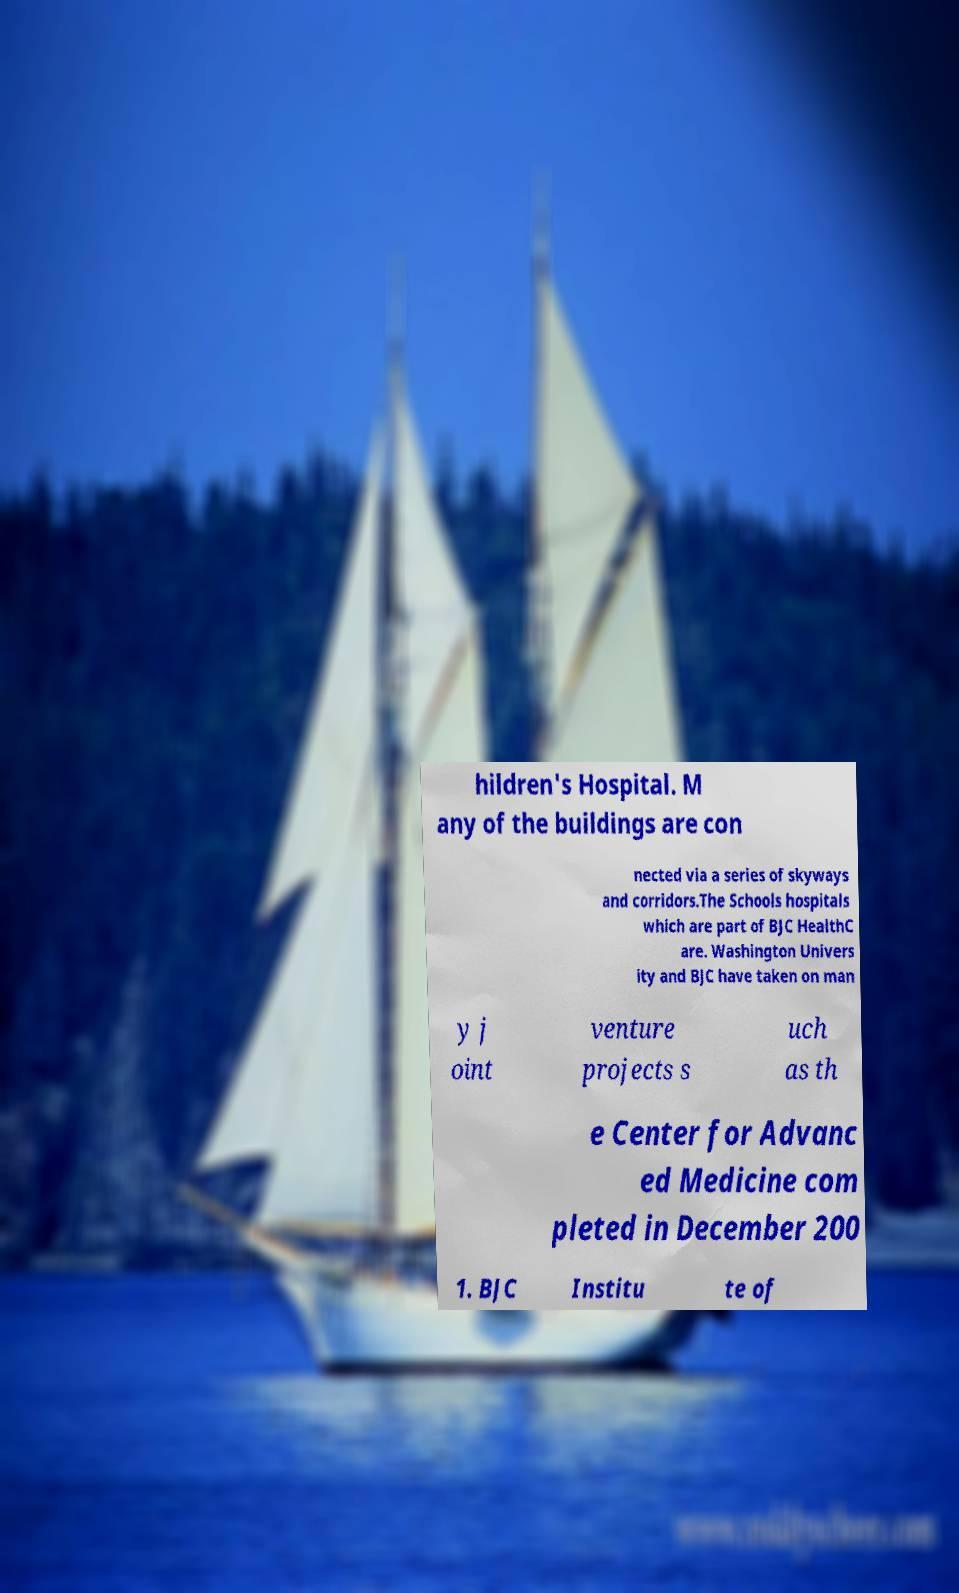Please identify and transcribe the text found in this image. hildren's Hospital. M any of the buildings are con nected via a series of skyways and corridors.The Schools hospitals which are part of BJC HealthC are. Washington Univers ity and BJC have taken on man y j oint venture projects s uch as th e Center for Advanc ed Medicine com pleted in December 200 1. BJC Institu te of 